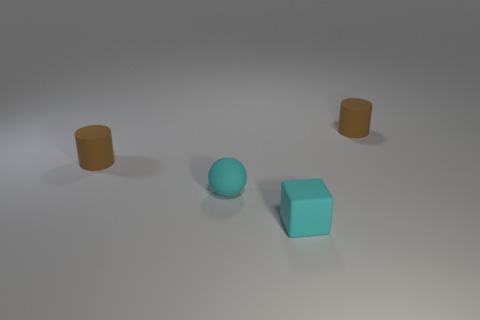Does the sphere have the same color as the tiny rubber block?
Your answer should be very brief. Yes. Is the number of objects that are in front of the small cyan matte block less than the number of spheres?
Make the answer very short. Yes. What shape is the small cyan object that is on the right side of the cyan thing that is behind the tiny cyan rubber thing that is in front of the small rubber sphere?
Offer a terse response. Cube. What is the shape of the cyan object that is the same size as the cyan matte block?
Offer a very short reply. Sphere. How many objects are tiny spheres or tiny cyan matte objects that are to the left of the small rubber block?
Ensure brevity in your answer.  1. There is a small matte cylinder left of the tiny matte cylinder that is on the right side of the tiny block; what number of small cylinders are behind it?
Your answer should be compact. 1. What color is the sphere that is the same material as the tiny cyan block?
Provide a short and direct response. Cyan. Is the size of the cyan thing behind the cyan matte cube the same as the small cube?
Your answer should be compact. Yes. What number of things are matte things or big yellow rubber blocks?
Provide a short and direct response. 4. What material is the small cyan ball that is left of the tiny cyan block?
Your answer should be compact. Rubber. 